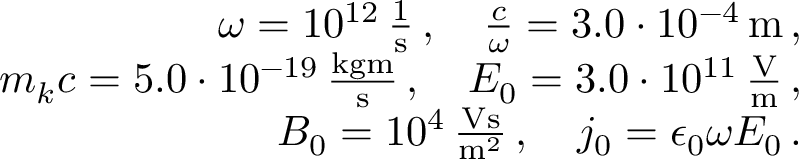<formula> <loc_0><loc_0><loc_500><loc_500>\begin{array} { r l r } & { \omega = 1 0 ^ { 1 2 } \, \frac { 1 } { s } \, , \quad \frac { c } { \omega } = 3 . 0 \cdot 1 0 ^ { - 4 } \, m \, , } \\ & { m _ { k } c = 5 . 0 \cdot 1 0 ^ { - 1 9 } \, \frac { k g m } { s } \, , \quad E _ { 0 } = 3 . 0 \cdot 1 0 ^ { 1 1 } \, \frac { V } { m } \, , } \\ & { B _ { 0 } = 1 0 ^ { 4 } \, \frac { V s } { m ^ { 2 } } \, , \quad j _ { 0 } = \epsilon _ { 0 } \omega E _ { 0 } \, . } \end{array}</formula> 